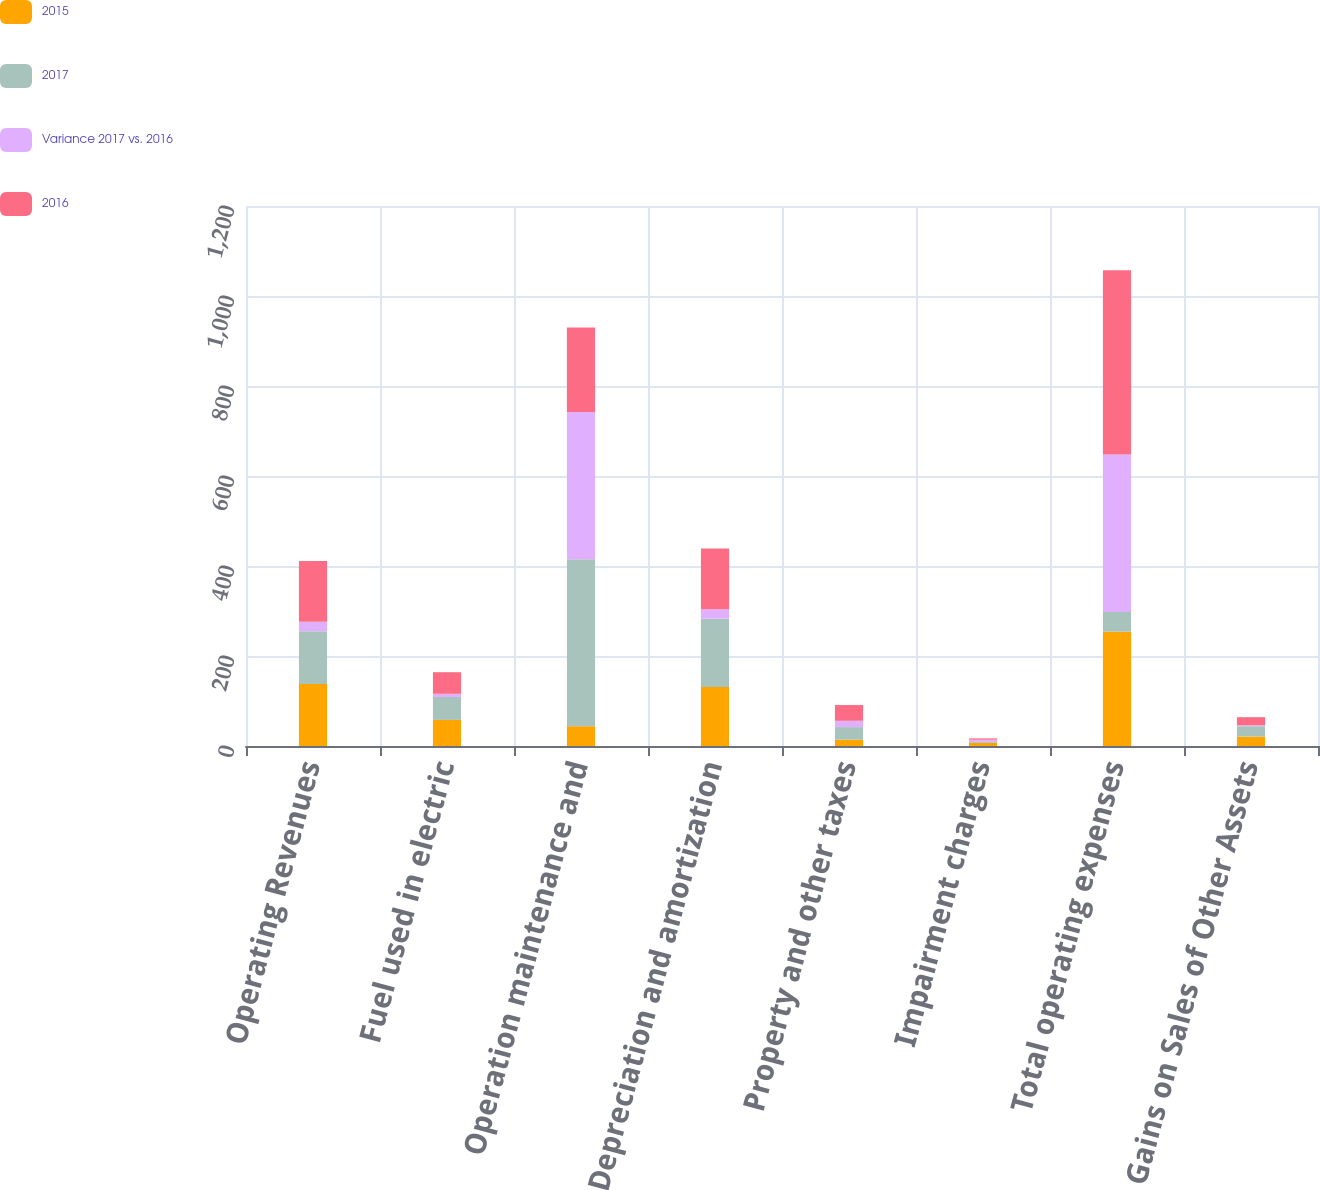<chart> <loc_0><loc_0><loc_500><loc_500><stacked_bar_chart><ecel><fcel>Operating Revenues<fcel>Fuel used in electric<fcel>Operation maintenance and<fcel>Depreciation and amortization<fcel>Property and other taxes<fcel>Impairment charges<fcel>Total operating expenses<fcel>Gains on Sales of Other Assets<nl><fcel>2015<fcel>138<fcel>58<fcel>44<fcel>131<fcel>14<fcel>7<fcel>254<fcel>21<nl><fcel>2017<fcel>117<fcel>51<fcel>371<fcel>152<fcel>28<fcel>2<fcel>44<fcel>23<nl><fcel>Variance 2017 vs. 2016<fcel>21<fcel>7<fcel>327<fcel>21<fcel>14<fcel>5<fcel>350<fcel>2<nl><fcel>2016<fcel>135<fcel>48<fcel>188<fcel>135<fcel>35<fcel>3<fcel>409<fcel>18<nl></chart> 